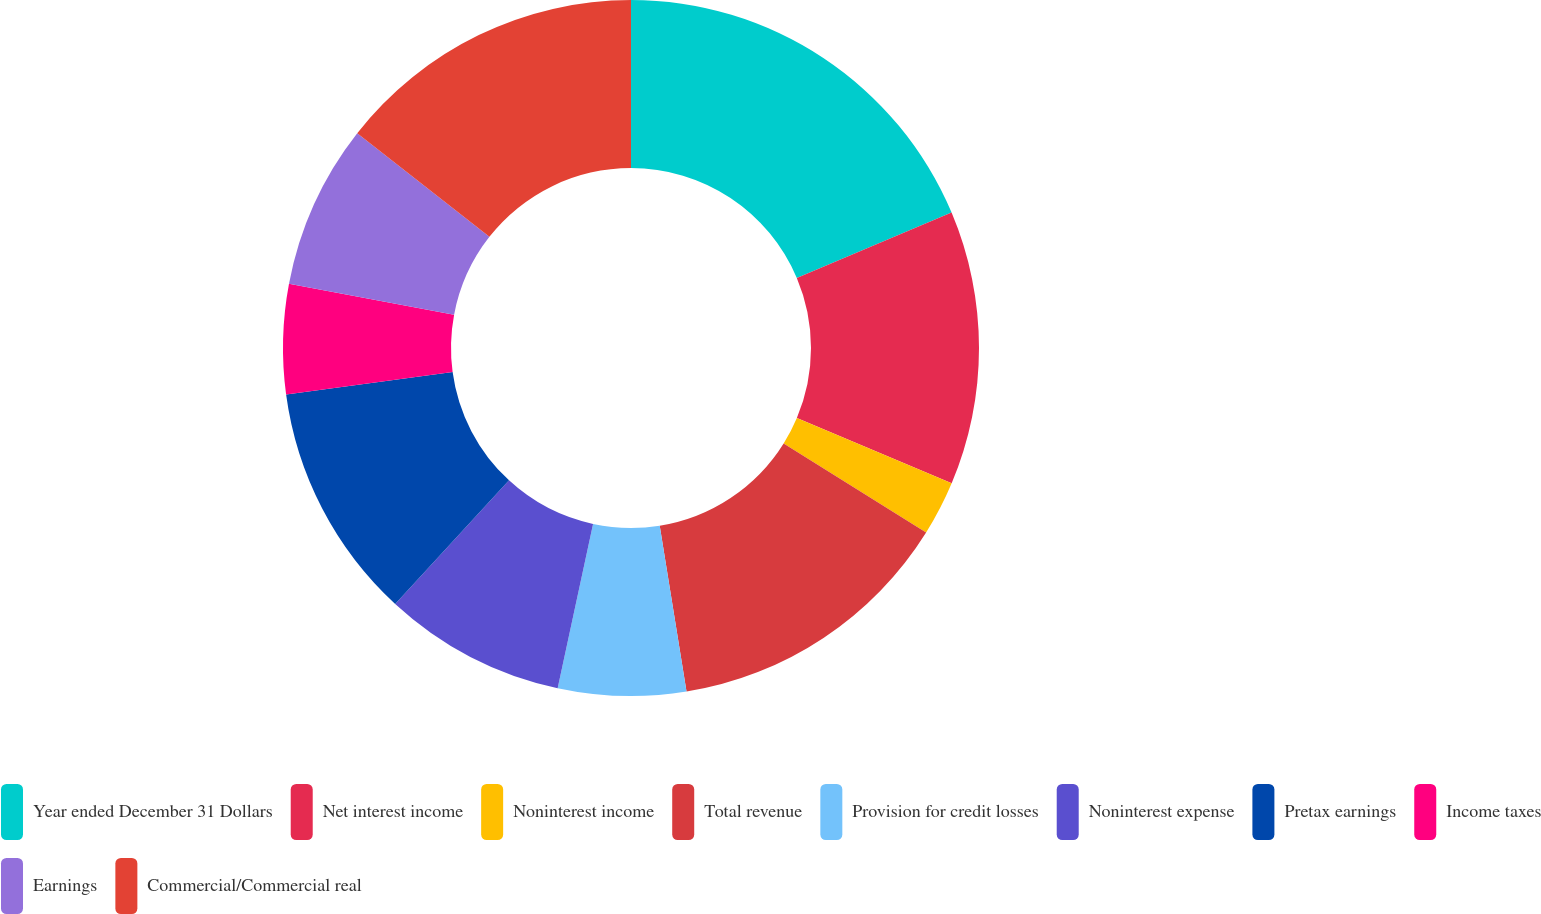Convert chart to OTSL. <chart><loc_0><loc_0><loc_500><loc_500><pie_chart><fcel>Year ended December 31 Dollars<fcel>Net interest income<fcel>Noninterest income<fcel>Total revenue<fcel>Provision for credit losses<fcel>Noninterest expense<fcel>Pretax earnings<fcel>Income taxes<fcel>Earnings<fcel>Commercial/Commercial real<nl><fcel>18.64%<fcel>12.71%<fcel>2.54%<fcel>13.56%<fcel>5.93%<fcel>8.47%<fcel>11.02%<fcel>5.09%<fcel>7.63%<fcel>14.41%<nl></chart> 